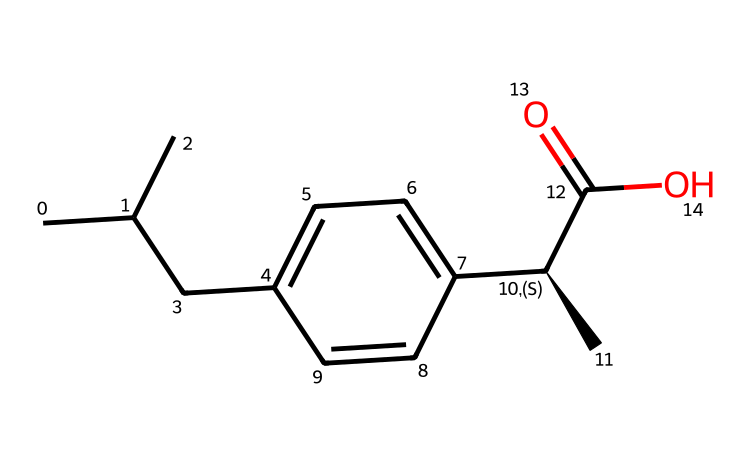How many carbon atoms are in ibuprofen? The SMILES representation CC(C)Cc1ccc(cc1)[C@H](C)C(=O)O shows there are multiple segments with carbon atoms. Counting them, there are 13 carbon atoms in total.
Answer: 13 What is the functional group present in ibuprofen? The chemical structure includes a carboxylic acid group marked by C(=O)O, which indicates that it is a functional group present within the molecule.
Answer: carboxylic acid How many double bonds are there in ibuprofen? Analyzing the SMILES, the structure includes only one double bond that exists within the carbonyl group (C=O) indicated in the structure.
Answer: 1 What type of molecules are primarily present in the structure of ibuprofen? The structure is composed mainly of hydrocarbon chains and an aromatic ring, evident through the presence of carbon and hydrogen atoms throughout the structure.
Answer: hydrocarbons Which part of the structure is responsible for ibuprofen's anti-inflammatory properties? The presence of the carboxylic acid functional group (C(=O)O) is typically associated with the mechanism of action of non-steroidal anti-inflammatory drugs, thereby contributing to its properties.
Answer: carboxylic acid What is the structural feature that indicates chirality in ibuprofen? The notation [C@H] in the SMILES indicates the presence of a chiral center within the molecule, signifying that it can exist in enantiomeric forms.
Answer: chiral center 